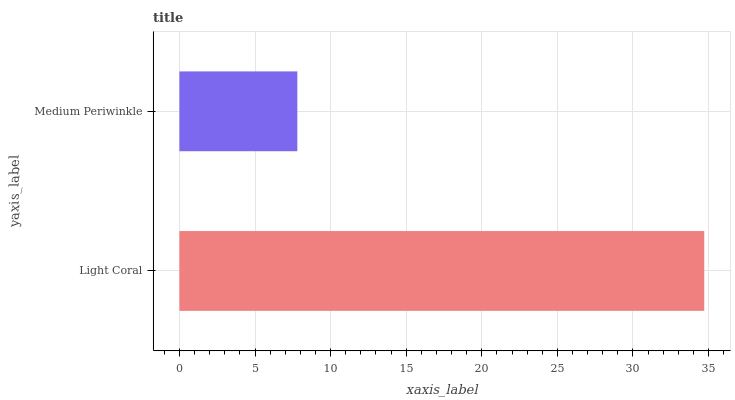Is Medium Periwinkle the minimum?
Answer yes or no. Yes. Is Light Coral the maximum?
Answer yes or no. Yes. Is Medium Periwinkle the maximum?
Answer yes or no. No. Is Light Coral greater than Medium Periwinkle?
Answer yes or no. Yes. Is Medium Periwinkle less than Light Coral?
Answer yes or no. Yes. Is Medium Periwinkle greater than Light Coral?
Answer yes or no. No. Is Light Coral less than Medium Periwinkle?
Answer yes or no. No. Is Light Coral the high median?
Answer yes or no. Yes. Is Medium Periwinkle the low median?
Answer yes or no. Yes. Is Medium Periwinkle the high median?
Answer yes or no. No. Is Light Coral the low median?
Answer yes or no. No. 